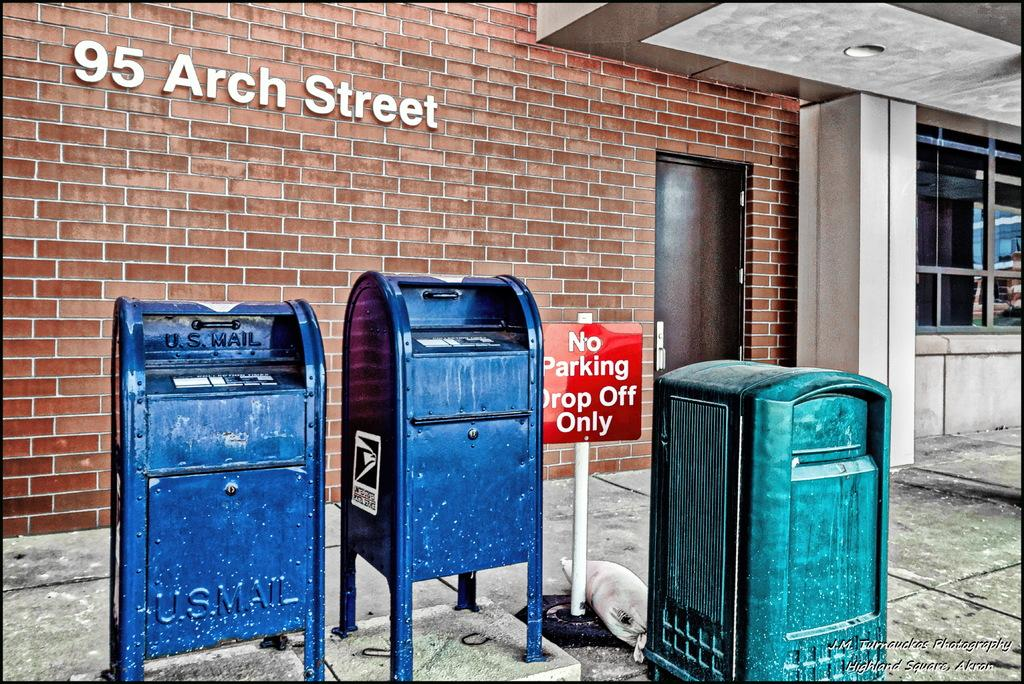<image>
Share a concise interpretation of the image provided. A red sign tells people that this spot is for drop off only, not parking. 